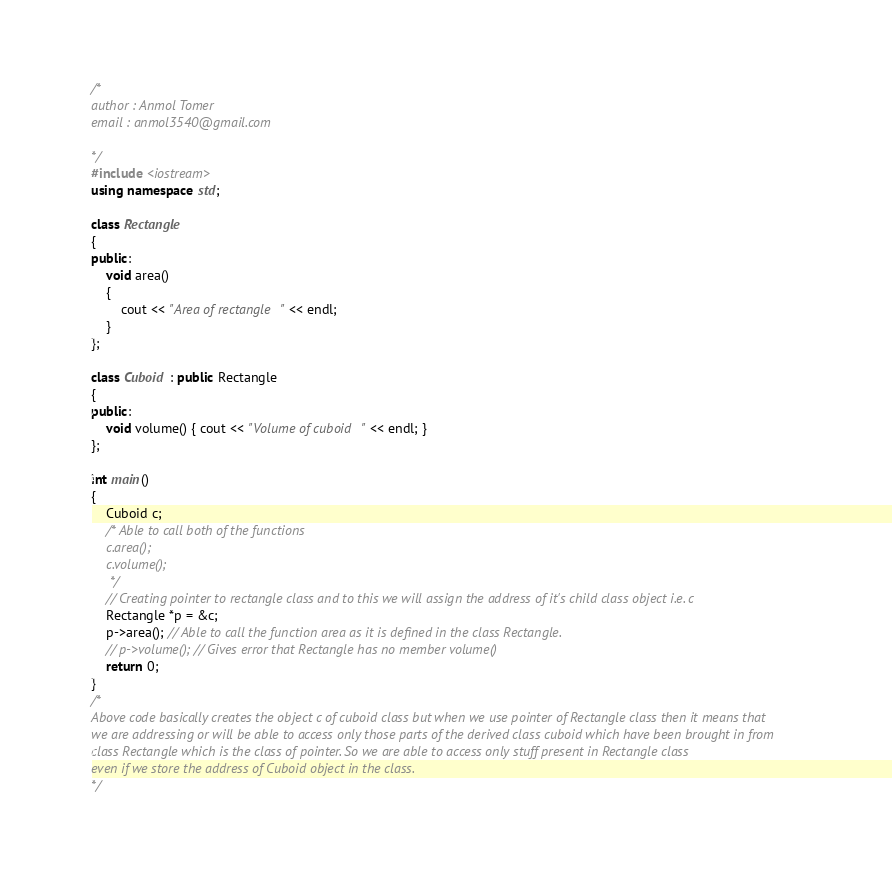Convert code to text. <code><loc_0><loc_0><loc_500><loc_500><_C++_>/*
author : Anmol Tomer
email : anmol3540@gmail.com

*/
#include <iostream>
using namespace std;

class Rectangle
{
public:
    void area()
    {
        cout << "Area of rectangle " << endl;
    }
};

class Cuboid : public Rectangle
{
public:
    void volume() { cout << "Volume of cuboid " << endl; }
};

int main()
{
    Cuboid c;
    /* Able to call both of the functions
    c.area();
    c.volume();
     */
    // Creating pointer to rectangle class and to this we will assign the address of it's child class object i.e. c
    Rectangle *p = &c;
    p->area(); // Able to call the function area as it is defined in the class Rectangle.
    // p->volume(); // Gives error that Rectangle has no member volume()
    return 0;
}
/*
Above code basically creates the object c of cuboid class but when we use pointer of Rectangle class then it means that
we are addressing or will be able to access only those parts of the derived class cuboid which have been brought in from
class Rectangle which is the class of pointer. So we are able to access only stuff present in Rectangle class
even if we store the address of Cuboid object in the class.
*/</code> 